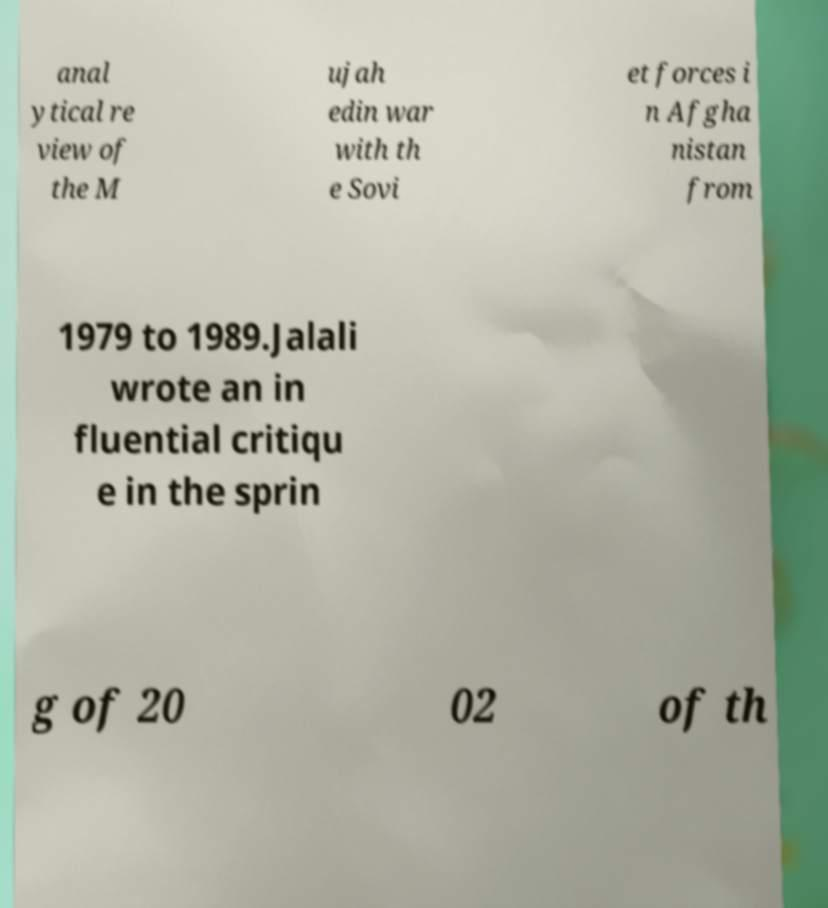Can you read and provide the text displayed in the image?This photo seems to have some interesting text. Can you extract and type it out for me? anal ytical re view of the M ujah edin war with th e Sovi et forces i n Afgha nistan from 1979 to 1989.Jalali wrote an in fluential critiqu e in the sprin g of 20 02 of th 